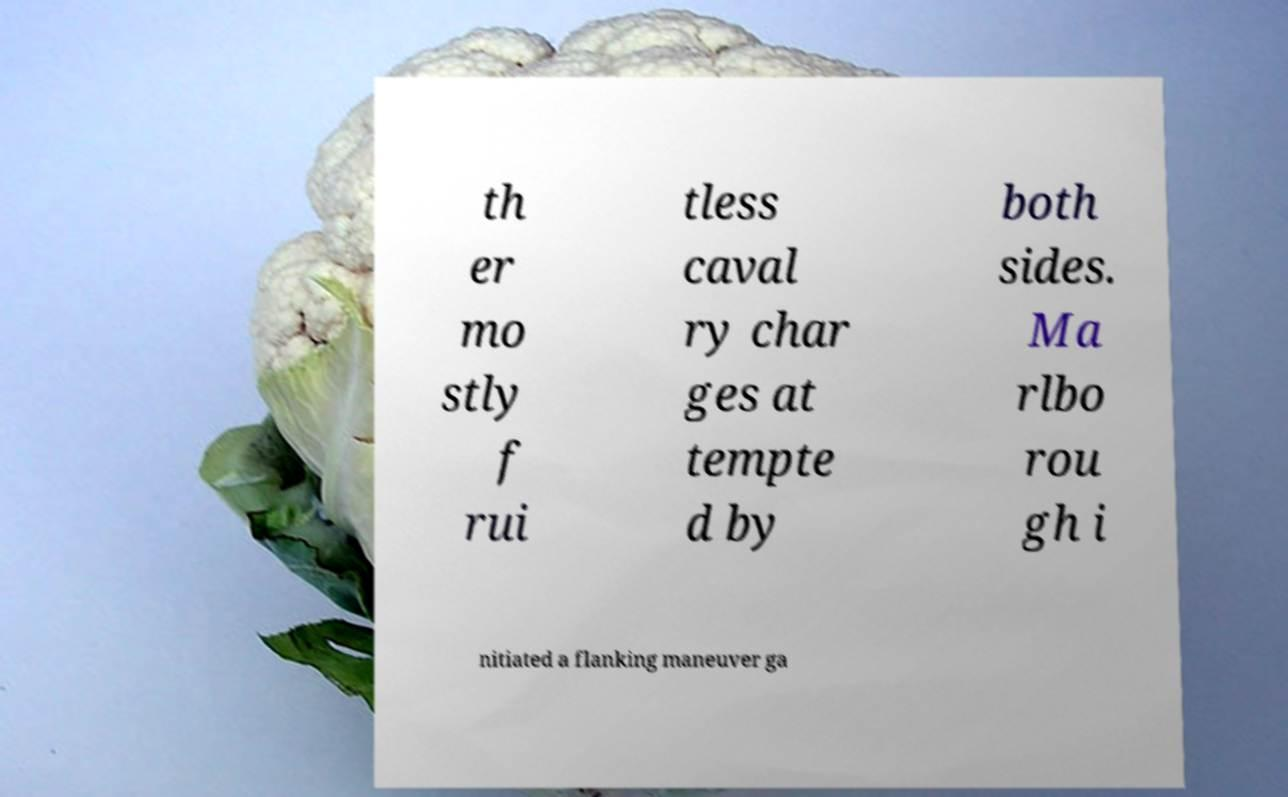What messages or text are displayed in this image? I need them in a readable, typed format. th er mo stly f rui tless caval ry char ges at tempte d by both sides. Ma rlbo rou gh i nitiated a flanking maneuver ga 